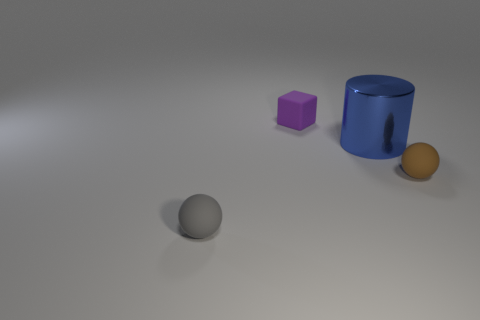Add 1 small objects. How many objects exist? 5 Subtract 1 cylinders. How many cylinders are left? 0 Subtract all blue cylinders. How many gray balls are left? 1 Subtract all brown spheres. How many spheres are left? 1 Subtract 0 blue blocks. How many objects are left? 4 Subtract all cylinders. How many objects are left? 3 Subtract all brown blocks. Subtract all green cylinders. How many blocks are left? 1 Subtract all large blue metal cylinders. Subtract all matte spheres. How many objects are left? 1 Add 4 large things. How many large things are left? 5 Add 1 tiny brown matte balls. How many tiny brown matte balls exist? 2 